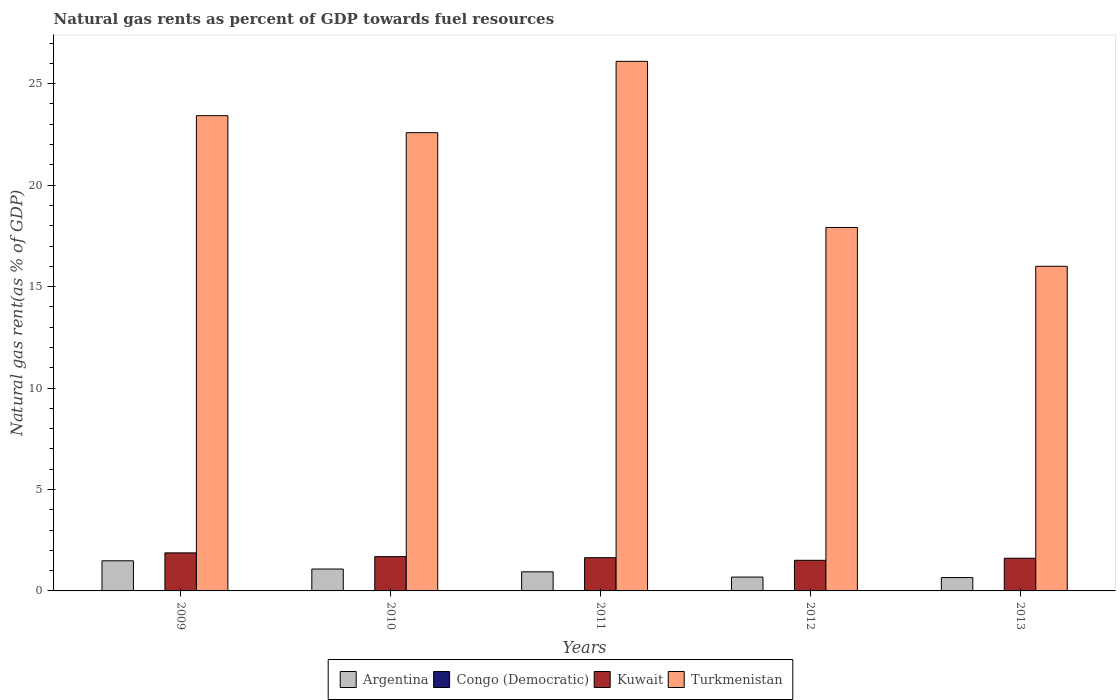How many bars are there on the 2nd tick from the left?
Your answer should be compact. 4. How many bars are there on the 1st tick from the right?
Your response must be concise. 4. What is the label of the 3rd group of bars from the left?
Make the answer very short. 2011. What is the natural gas rent in Turkmenistan in 2010?
Offer a very short reply. 22.59. Across all years, what is the maximum natural gas rent in Kuwait?
Your response must be concise. 1.88. Across all years, what is the minimum natural gas rent in Kuwait?
Your answer should be very brief. 1.51. What is the total natural gas rent in Congo (Democratic) in the graph?
Make the answer very short. 0.03. What is the difference between the natural gas rent in Argentina in 2009 and that in 2013?
Your answer should be very brief. 0.83. What is the difference between the natural gas rent in Congo (Democratic) in 2011 and the natural gas rent in Turkmenistan in 2010?
Your response must be concise. -22.58. What is the average natural gas rent in Argentina per year?
Ensure brevity in your answer.  0.97. In the year 2012, what is the difference between the natural gas rent in Congo (Democratic) and natural gas rent in Kuwait?
Give a very brief answer. -1.5. In how many years, is the natural gas rent in Turkmenistan greater than 21 %?
Your response must be concise. 3. What is the ratio of the natural gas rent in Kuwait in 2009 to that in 2010?
Provide a succinct answer. 1.11. Is the natural gas rent in Turkmenistan in 2009 less than that in 2011?
Make the answer very short. Yes. Is the difference between the natural gas rent in Congo (Democratic) in 2011 and 2012 greater than the difference between the natural gas rent in Kuwait in 2011 and 2012?
Offer a terse response. No. What is the difference between the highest and the second highest natural gas rent in Turkmenistan?
Make the answer very short. 2.68. What is the difference between the highest and the lowest natural gas rent in Kuwait?
Your answer should be very brief. 0.37. In how many years, is the natural gas rent in Congo (Democratic) greater than the average natural gas rent in Congo (Democratic) taken over all years?
Keep it short and to the point. 3. What does the 4th bar from the left in 2011 represents?
Offer a very short reply. Turkmenistan. What does the 1st bar from the right in 2013 represents?
Offer a terse response. Turkmenistan. How many bars are there?
Keep it short and to the point. 20. Are all the bars in the graph horizontal?
Make the answer very short. No. Are the values on the major ticks of Y-axis written in scientific E-notation?
Your response must be concise. No. Does the graph contain grids?
Give a very brief answer. No. Where does the legend appear in the graph?
Offer a terse response. Bottom center. How are the legend labels stacked?
Make the answer very short. Horizontal. What is the title of the graph?
Offer a terse response. Natural gas rents as percent of GDP towards fuel resources. What is the label or title of the Y-axis?
Offer a terse response. Natural gas rent(as % of GDP). What is the Natural gas rent(as % of GDP) in Argentina in 2009?
Provide a short and direct response. 1.48. What is the Natural gas rent(as % of GDP) of Congo (Democratic) in 2009?
Ensure brevity in your answer.  0.01. What is the Natural gas rent(as % of GDP) in Kuwait in 2009?
Provide a succinct answer. 1.88. What is the Natural gas rent(as % of GDP) in Turkmenistan in 2009?
Your answer should be very brief. 23.42. What is the Natural gas rent(as % of GDP) of Argentina in 2010?
Provide a succinct answer. 1.08. What is the Natural gas rent(as % of GDP) of Congo (Democratic) in 2010?
Give a very brief answer. 0.01. What is the Natural gas rent(as % of GDP) of Kuwait in 2010?
Make the answer very short. 1.69. What is the Natural gas rent(as % of GDP) in Turkmenistan in 2010?
Offer a very short reply. 22.59. What is the Natural gas rent(as % of GDP) of Argentina in 2011?
Ensure brevity in your answer.  0.94. What is the Natural gas rent(as % of GDP) of Congo (Democratic) in 2011?
Your response must be concise. 0.01. What is the Natural gas rent(as % of GDP) in Kuwait in 2011?
Ensure brevity in your answer.  1.64. What is the Natural gas rent(as % of GDP) in Turkmenistan in 2011?
Provide a short and direct response. 26.1. What is the Natural gas rent(as % of GDP) in Argentina in 2012?
Offer a terse response. 0.68. What is the Natural gas rent(as % of GDP) in Congo (Democratic) in 2012?
Your response must be concise. 0. What is the Natural gas rent(as % of GDP) in Kuwait in 2012?
Provide a short and direct response. 1.51. What is the Natural gas rent(as % of GDP) in Turkmenistan in 2012?
Provide a succinct answer. 17.91. What is the Natural gas rent(as % of GDP) of Argentina in 2013?
Give a very brief answer. 0.66. What is the Natural gas rent(as % of GDP) of Congo (Democratic) in 2013?
Keep it short and to the point. 0. What is the Natural gas rent(as % of GDP) in Kuwait in 2013?
Offer a very short reply. 1.61. What is the Natural gas rent(as % of GDP) of Turkmenistan in 2013?
Keep it short and to the point. 16. Across all years, what is the maximum Natural gas rent(as % of GDP) of Argentina?
Make the answer very short. 1.48. Across all years, what is the maximum Natural gas rent(as % of GDP) of Congo (Democratic)?
Your answer should be very brief. 0.01. Across all years, what is the maximum Natural gas rent(as % of GDP) of Kuwait?
Give a very brief answer. 1.88. Across all years, what is the maximum Natural gas rent(as % of GDP) of Turkmenistan?
Offer a terse response. 26.1. Across all years, what is the minimum Natural gas rent(as % of GDP) in Argentina?
Your answer should be compact. 0.66. Across all years, what is the minimum Natural gas rent(as % of GDP) of Congo (Democratic)?
Your answer should be compact. 0. Across all years, what is the minimum Natural gas rent(as % of GDP) in Kuwait?
Provide a succinct answer. 1.51. Across all years, what is the minimum Natural gas rent(as % of GDP) of Turkmenistan?
Ensure brevity in your answer.  16. What is the total Natural gas rent(as % of GDP) of Argentina in the graph?
Provide a succinct answer. 4.85. What is the total Natural gas rent(as % of GDP) in Congo (Democratic) in the graph?
Provide a short and direct response. 0.03. What is the total Natural gas rent(as % of GDP) in Kuwait in the graph?
Offer a very short reply. 8.32. What is the total Natural gas rent(as % of GDP) in Turkmenistan in the graph?
Your answer should be very brief. 106.03. What is the difference between the Natural gas rent(as % of GDP) in Argentina in 2009 and that in 2010?
Provide a succinct answer. 0.41. What is the difference between the Natural gas rent(as % of GDP) in Congo (Democratic) in 2009 and that in 2010?
Your answer should be very brief. 0. What is the difference between the Natural gas rent(as % of GDP) of Kuwait in 2009 and that in 2010?
Give a very brief answer. 0.19. What is the difference between the Natural gas rent(as % of GDP) of Turkmenistan in 2009 and that in 2010?
Offer a very short reply. 0.84. What is the difference between the Natural gas rent(as % of GDP) of Argentina in 2009 and that in 2011?
Provide a short and direct response. 0.54. What is the difference between the Natural gas rent(as % of GDP) of Congo (Democratic) in 2009 and that in 2011?
Make the answer very short. 0. What is the difference between the Natural gas rent(as % of GDP) in Kuwait in 2009 and that in 2011?
Give a very brief answer. 0.24. What is the difference between the Natural gas rent(as % of GDP) in Turkmenistan in 2009 and that in 2011?
Make the answer very short. -2.68. What is the difference between the Natural gas rent(as % of GDP) of Argentina in 2009 and that in 2012?
Keep it short and to the point. 0.8. What is the difference between the Natural gas rent(as % of GDP) in Congo (Democratic) in 2009 and that in 2012?
Provide a succinct answer. 0. What is the difference between the Natural gas rent(as % of GDP) of Kuwait in 2009 and that in 2012?
Keep it short and to the point. 0.37. What is the difference between the Natural gas rent(as % of GDP) in Turkmenistan in 2009 and that in 2012?
Offer a terse response. 5.51. What is the difference between the Natural gas rent(as % of GDP) in Argentina in 2009 and that in 2013?
Make the answer very short. 0.83. What is the difference between the Natural gas rent(as % of GDP) of Congo (Democratic) in 2009 and that in 2013?
Offer a terse response. 0. What is the difference between the Natural gas rent(as % of GDP) in Kuwait in 2009 and that in 2013?
Your response must be concise. 0.26. What is the difference between the Natural gas rent(as % of GDP) of Turkmenistan in 2009 and that in 2013?
Make the answer very short. 7.42. What is the difference between the Natural gas rent(as % of GDP) in Argentina in 2010 and that in 2011?
Ensure brevity in your answer.  0.14. What is the difference between the Natural gas rent(as % of GDP) in Kuwait in 2010 and that in 2011?
Your answer should be very brief. 0.05. What is the difference between the Natural gas rent(as % of GDP) in Turkmenistan in 2010 and that in 2011?
Keep it short and to the point. -3.52. What is the difference between the Natural gas rent(as % of GDP) of Argentina in 2010 and that in 2012?
Your answer should be compact. 0.4. What is the difference between the Natural gas rent(as % of GDP) of Congo (Democratic) in 2010 and that in 2012?
Make the answer very short. 0. What is the difference between the Natural gas rent(as % of GDP) of Kuwait in 2010 and that in 2012?
Provide a short and direct response. 0.18. What is the difference between the Natural gas rent(as % of GDP) in Turkmenistan in 2010 and that in 2012?
Offer a very short reply. 4.67. What is the difference between the Natural gas rent(as % of GDP) of Argentina in 2010 and that in 2013?
Your response must be concise. 0.42. What is the difference between the Natural gas rent(as % of GDP) in Congo (Democratic) in 2010 and that in 2013?
Keep it short and to the point. 0. What is the difference between the Natural gas rent(as % of GDP) in Kuwait in 2010 and that in 2013?
Your answer should be compact. 0.08. What is the difference between the Natural gas rent(as % of GDP) of Turkmenistan in 2010 and that in 2013?
Your answer should be very brief. 6.59. What is the difference between the Natural gas rent(as % of GDP) of Argentina in 2011 and that in 2012?
Offer a terse response. 0.26. What is the difference between the Natural gas rent(as % of GDP) of Congo (Democratic) in 2011 and that in 2012?
Ensure brevity in your answer.  0. What is the difference between the Natural gas rent(as % of GDP) in Kuwait in 2011 and that in 2012?
Provide a succinct answer. 0.13. What is the difference between the Natural gas rent(as % of GDP) in Turkmenistan in 2011 and that in 2012?
Your answer should be very brief. 8.19. What is the difference between the Natural gas rent(as % of GDP) in Argentina in 2011 and that in 2013?
Your answer should be very brief. 0.28. What is the difference between the Natural gas rent(as % of GDP) of Congo (Democratic) in 2011 and that in 2013?
Keep it short and to the point. 0. What is the difference between the Natural gas rent(as % of GDP) in Kuwait in 2011 and that in 2013?
Ensure brevity in your answer.  0.03. What is the difference between the Natural gas rent(as % of GDP) in Turkmenistan in 2011 and that in 2013?
Provide a short and direct response. 10.1. What is the difference between the Natural gas rent(as % of GDP) in Argentina in 2012 and that in 2013?
Your answer should be very brief. 0.02. What is the difference between the Natural gas rent(as % of GDP) of Kuwait in 2012 and that in 2013?
Provide a succinct answer. -0.1. What is the difference between the Natural gas rent(as % of GDP) in Turkmenistan in 2012 and that in 2013?
Offer a very short reply. 1.91. What is the difference between the Natural gas rent(as % of GDP) in Argentina in 2009 and the Natural gas rent(as % of GDP) in Congo (Democratic) in 2010?
Give a very brief answer. 1.48. What is the difference between the Natural gas rent(as % of GDP) of Argentina in 2009 and the Natural gas rent(as % of GDP) of Kuwait in 2010?
Offer a very short reply. -0.2. What is the difference between the Natural gas rent(as % of GDP) of Argentina in 2009 and the Natural gas rent(as % of GDP) of Turkmenistan in 2010?
Offer a terse response. -21.1. What is the difference between the Natural gas rent(as % of GDP) of Congo (Democratic) in 2009 and the Natural gas rent(as % of GDP) of Kuwait in 2010?
Offer a very short reply. -1.68. What is the difference between the Natural gas rent(as % of GDP) in Congo (Democratic) in 2009 and the Natural gas rent(as % of GDP) in Turkmenistan in 2010?
Keep it short and to the point. -22.58. What is the difference between the Natural gas rent(as % of GDP) in Kuwait in 2009 and the Natural gas rent(as % of GDP) in Turkmenistan in 2010?
Your response must be concise. -20.71. What is the difference between the Natural gas rent(as % of GDP) of Argentina in 2009 and the Natural gas rent(as % of GDP) of Congo (Democratic) in 2011?
Keep it short and to the point. 1.48. What is the difference between the Natural gas rent(as % of GDP) in Argentina in 2009 and the Natural gas rent(as % of GDP) in Kuwait in 2011?
Offer a terse response. -0.15. What is the difference between the Natural gas rent(as % of GDP) in Argentina in 2009 and the Natural gas rent(as % of GDP) in Turkmenistan in 2011?
Give a very brief answer. -24.62. What is the difference between the Natural gas rent(as % of GDP) in Congo (Democratic) in 2009 and the Natural gas rent(as % of GDP) in Kuwait in 2011?
Ensure brevity in your answer.  -1.63. What is the difference between the Natural gas rent(as % of GDP) in Congo (Democratic) in 2009 and the Natural gas rent(as % of GDP) in Turkmenistan in 2011?
Make the answer very short. -26.09. What is the difference between the Natural gas rent(as % of GDP) in Kuwait in 2009 and the Natural gas rent(as % of GDP) in Turkmenistan in 2011?
Offer a very short reply. -24.23. What is the difference between the Natural gas rent(as % of GDP) of Argentina in 2009 and the Natural gas rent(as % of GDP) of Congo (Democratic) in 2012?
Make the answer very short. 1.48. What is the difference between the Natural gas rent(as % of GDP) of Argentina in 2009 and the Natural gas rent(as % of GDP) of Kuwait in 2012?
Provide a succinct answer. -0.02. What is the difference between the Natural gas rent(as % of GDP) of Argentina in 2009 and the Natural gas rent(as % of GDP) of Turkmenistan in 2012?
Your response must be concise. -16.43. What is the difference between the Natural gas rent(as % of GDP) in Congo (Democratic) in 2009 and the Natural gas rent(as % of GDP) in Kuwait in 2012?
Your response must be concise. -1.5. What is the difference between the Natural gas rent(as % of GDP) in Congo (Democratic) in 2009 and the Natural gas rent(as % of GDP) in Turkmenistan in 2012?
Provide a short and direct response. -17.91. What is the difference between the Natural gas rent(as % of GDP) of Kuwait in 2009 and the Natural gas rent(as % of GDP) of Turkmenistan in 2012?
Your response must be concise. -16.04. What is the difference between the Natural gas rent(as % of GDP) in Argentina in 2009 and the Natural gas rent(as % of GDP) in Congo (Democratic) in 2013?
Offer a very short reply. 1.48. What is the difference between the Natural gas rent(as % of GDP) of Argentina in 2009 and the Natural gas rent(as % of GDP) of Kuwait in 2013?
Keep it short and to the point. -0.13. What is the difference between the Natural gas rent(as % of GDP) of Argentina in 2009 and the Natural gas rent(as % of GDP) of Turkmenistan in 2013?
Your answer should be compact. -14.52. What is the difference between the Natural gas rent(as % of GDP) of Congo (Democratic) in 2009 and the Natural gas rent(as % of GDP) of Kuwait in 2013?
Keep it short and to the point. -1.6. What is the difference between the Natural gas rent(as % of GDP) in Congo (Democratic) in 2009 and the Natural gas rent(as % of GDP) in Turkmenistan in 2013?
Your answer should be compact. -15.99. What is the difference between the Natural gas rent(as % of GDP) of Kuwait in 2009 and the Natural gas rent(as % of GDP) of Turkmenistan in 2013?
Provide a short and direct response. -14.12. What is the difference between the Natural gas rent(as % of GDP) in Argentina in 2010 and the Natural gas rent(as % of GDP) in Congo (Democratic) in 2011?
Provide a succinct answer. 1.07. What is the difference between the Natural gas rent(as % of GDP) in Argentina in 2010 and the Natural gas rent(as % of GDP) in Kuwait in 2011?
Offer a terse response. -0.56. What is the difference between the Natural gas rent(as % of GDP) of Argentina in 2010 and the Natural gas rent(as % of GDP) of Turkmenistan in 2011?
Give a very brief answer. -25.02. What is the difference between the Natural gas rent(as % of GDP) in Congo (Democratic) in 2010 and the Natural gas rent(as % of GDP) in Kuwait in 2011?
Provide a succinct answer. -1.63. What is the difference between the Natural gas rent(as % of GDP) of Congo (Democratic) in 2010 and the Natural gas rent(as % of GDP) of Turkmenistan in 2011?
Keep it short and to the point. -26.1. What is the difference between the Natural gas rent(as % of GDP) of Kuwait in 2010 and the Natural gas rent(as % of GDP) of Turkmenistan in 2011?
Your answer should be compact. -24.41. What is the difference between the Natural gas rent(as % of GDP) of Argentina in 2010 and the Natural gas rent(as % of GDP) of Congo (Democratic) in 2012?
Provide a short and direct response. 1.07. What is the difference between the Natural gas rent(as % of GDP) in Argentina in 2010 and the Natural gas rent(as % of GDP) in Kuwait in 2012?
Offer a very short reply. -0.43. What is the difference between the Natural gas rent(as % of GDP) in Argentina in 2010 and the Natural gas rent(as % of GDP) in Turkmenistan in 2012?
Make the answer very short. -16.83. What is the difference between the Natural gas rent(as % of GDP) in Congo (Democratic) in 2010 and the Natural gas rent(as % of GDP) in Kuwait in 2012?
Make the answer very short. -1.5. What is the difference between the Natural gas rent(as % of GDP) of Congo (Democratic) in 2010 and the Natural gas rent(as % of GDP) of Turkmenistan in 2012?
Your answer should be compact. -17.91. What is the difference between the Natural gas rent(as % of GDP) in Kuwait in 2010 and the Natural gas rent(as % of GDP) in Turkmenistan in 2012?
Provide a succinct answer. -16.22. What is the difference between the Natural gas rent(as % of GDP) in Argentina in 2010 and the Natural gas rent(as % of GDP) in Congo (Democratic) in 2013?
Offer a very short reply. 1.07. What is the difference between the Natural gas rent(as % of GDP) in Argentina in 2010 and the Natural gas rent(as % of GDP) in Kuwait in 2013?
Your answer should be compact. -0.53. What is the difference between the Natural gas rent(as % of GDP) in Argentina in 2010 and the Natural gas rent(as % of GDP) in Turkmenistan in 2013?
Provide a succinct answer. -14.92. What is the difference between the Natural gas rent(as % of GDP) in Congo (Democratic) in 2010 and the Natural gas rent(as % of GDP) in Kuwait in 2013?
Make the answer very short. -1.61. What is the difference between the Natural gas rent(as % of GDP) of Congo (Democratic) in 2010 and the Natural gas rent(as % of GDP) of Turkmenistan in 2013?
Give a very brief answer. -15.99. What is the difference between the Natural gas rent(as % of GDP) in Kuwait in 2010 and the Natural gas rent(as % of GDP) in Turkmenistan in 2013?
Your response must be concise. -14.31. What is the difference between the Natural gas rent(as % of GDP) of Argentina in 2011 and the Natural gas rent(as % of GDP) of Congo (Democratic) in 2012?
Provide a succinct answer. 0.94. What is the difference between the Natural gas rent(as % of GDP) of Argentina in 2011 and the Natural gas rent(as % of GDP) of Kuwait in 2012?
Give a very brief answer. -0.57. What is the difference between the Natural gas rent(as % of GDP) in Argentina in 2011 and the Natural gas rent(as % of GDP) in Turkmenistan in 2012?
Offer a terse response. -16.97. What is the difference between the Natural gas rent(as % of GDP) of Congo (Democratic) in 2011 and the Natural gas rent(as % of GDP) of Kuwait in 2012?
Your answer should be compact. -1.5. What is the difference between the Natural gas rent(as % of GDP) of Congo (Democratic) in 2011 and the Natural gas rent(as % of GDP) of Turkmenistan in 2012?
Keep it short and to the point. -17.91. What is the difference between the Natural gas rent(as % of GDP) of Kuwait in 2011 and the Natural gas rent(as % of GDP) of Turkmenistan in 2012?
Keep it short and to the point. -16.28. What is the difference between the Natural gas rent(as % of GDP) in Argentina in 2011 and the Natural gas rent(as % of GDP) in Congo (Democratic) in 2013?
Your answer should be very brief. 0.94. What is the difference between the Natural gas rent(as % of GDP) in Argentina in 2011 and the Natural gas rent(as % of GDP) in Kuwait in 2013?
Keep it short and to the point. -0.67. What is the difference between the Natural gas rent(as % of GDP) in Argentina in 2011 and the Natural gas rent(as % of GDP) in Turkmenistan in 2013?
Keep it short and to the point. -15.06. What is the difference between the Natural gas rent(as % of GDP) of Congo (Democratic) in 2011 and the Natural gas rent(as % of GDP) of Kuwait in 2013?
Give a very brief answer. -1.61. What is the difference between the Natural gas rent(as % of GDP) of Congo (Democratic) in 2011 and the Natural gas rent(as % of GDP) of Turkmenistan in 2013?
Make the answer very short. -15.99. What is the difference between the Natural gas rent(as % of GDP) in Kuwait in 2011 and the Natural gas rent(as % of GDP) in Turkmenistan in 2013?
Give a very brief answer. -14.36. What is the difference between the Natural gas rent(as % of GDP) of Argentina in 2012 and the Natural gas rent(as % of GDP) of Congo (Democratic) in 2013?
Offer a terse response. 0.68. What is the difference between the Natural gas rent(as % of GDP) of Argentina in 2012 and the Natural gas rent(as % of GDP) of Kuwait in 2013?
Ensure brevity in your answer.  -0.93. What is the difference between the Natural gas rent(as % of GDP) in Argentina in 2012 and the Natural gas rent(as % of GDP) in Turkmenistan in 2013?
Your answer should be compact. -15.32. What is the difference between the Natural gas rent(as % of GDP) of Congo (Democratic) in 2012 and the Natural gas rent(as % of GDP) of Kuwait in 2013?
Make the answer very short. -1.61. What is the difference between the Natural gas rent(as % of GDP) of Congo (Democratic) in 2012 and the Natural gas rent(as % of GDP) of Turkmenistan in 2013?
Provide a short and direct response. -16. What is the difference between the Natural gas rent(as % of GDP) of Kuwait in 2012 and the Natural gas rent(as % of GDP) of Turkmenistan in 2013?
Your answer should be compact. -14.49. What is the average Natural gas rent(as % of GDP) in Argentina per year?
Your answer should be compact. 0.97. What is the average Natural gas rent(as % of GDP) of Congo (Democratic) per year?
Provide a short and direct response. 0.01. What is the average Natural gas rent(as % of GDP) in Kuwait per year?
Give a very brief answer. 1.66. What is the average Natural gas rent(as % of GDP) in Turkmenistan per year?
Offer a terse response. 21.21. In the year 2009, what is the difference between the Natural gas rent(as % of GDP) of Argentina and Natural gas rent(as % of GDP) of Congo (Democratic)?
Give a very brief answer. 1.48. In the year 2009, what is the difference between the Natural gas rent(as % of GDP) of Argentina and Natural gas rent(as % of GDP) of Kuwait?
Give a very brief answer. -0.39. In the year 2009, what is the difference between the Natural gas rent(as % of GDP) of Argentina and Natural gas rent(as % of GDP) of Turkmenistan?
Your answer should be compact. -21.94. In the year 2009, what is the difference between the Natural gas rent(as % of GDP) of Congo (Democratic) and Natural gas rent(as % of GDP) of Kuwait?
Ensure brevity in your answer.  -1.87. In the year 2009, what is the difference between the Natural gas rent(as % of GDP) in Congo (Democratic) and Natural gas rent(as % of GDP) in Turkmenistan?
Give a very brief answer. -23.42. In the year 2009, what is the difference between the Natural gas rent(as % of GDP) of Kuwait and Natural gas rent(as % of GDP) of Turkmenistan?
Provide a succinct answer. -21.55. In the year 2010, what is the difference between the Natural gas rent(as % of GDP) of Argentina and Natural gas rent(as % of GDP) of Congo (Democratic)?
Your answer should be compact. 1.07. In the year 2010, what is the difference between the Natural gas rent(as % of GDP) of Argentina and Natural gas rent(as % of GDP) of Kuwait?
Keep it short and to the point. -0.61. In the year 2010, what is the difference between the Natural gas rent(as % of GDP) of Argentina and Natural gas rent(as % of GDP) of Turkmenistan?
Your answer should be compact. -21.51. In the year 2010, what is the difference between the Natural gas rent(as % of GDP) in Congo (Democratic) and Natural gas rent(as % of GDP) in Kuwait?
Make the answer very short. -1.68. In the year 2010, what is the difference between the Natural gas rent(as % of GDP) in Congo (Democratic) and Natural gas rent(as % of GDP) in Turkmenistan?
Make the answer very short. -22.58. In the year 2010, what is the difference between the Natural gas rent(as % of GDP) of Kuwait and Natural gas rent(as % of GDP) of Turkmenistan?
Offer a terse response. -20.9. In the year 2011, what is the difference between the Natural gas rent(as % of GDP) of Argentina and Natural gas rent(as % of GDP) of Congo (Democratic)?
Provide a succinct answer. 0.94. In the year 2011, what is the difference between the Natural gas rent(as % of GDP) of Argentina and Natural gas rent(as % of GDP) of Kuwait?
Give a very brief answer. -0.7. In the year 2011, what is the difference between the Natural gas rent(as % of GDP) of Argentina and Natural gas rent(as % of GDP) of Turkmenistan?
Offer a very short reply. -25.16. In the year 2011, what is the difference between the Natural gas rent(as % of GDP) of Congo (Democratic) and Natural gas rent(as % of GDP) of Kuwait?
Provide a short and direct response. -1.63. In the year 2011, what is the difference between the Natural gas rent(as % of GDP) in Congo (Democratic) and Natural gas rent(as % of GDP) in Turkmenistan?
Give a very brief answer. -26.1. In the year 2011, what is the difference between the Natural gas rent(as % of GDP) of Kuwait and Natural gas rent(as % of GDP) of Turkmenistan?
Offer a very short reply. -24.46. In the year 2012, what is the difference between the Natural gas rent(as % of GDP) in Argentina and Natural gas rent(as % of GDP) in Congo (Democratic)?
Offer a very short reply. 0.68. In the year 2012, what is the difference between the Natural gas rent(as % of GDP) of Argentina and Natural gas rent(as % of GDP) of Kuwait?
Provide a short and direct response. -0.83. In the year 2012, what is the difference between the Natural gas rent(as % of GDP) in Argentina and Natural gas rent(as % of GDP) in Turkmenistan?
Make the answer very short. -17.23. In the year 2012, what is the difference between the Natural gas rent(as % of GDP) in Congo (Democratic) and Natural gas rent(as % of GDP) in Kuwait?
Keep it short and to the point. -1.5. In the year 2012, what is the difference between the Natural gas rent(as % of GDP) of Congo (Democratic) and Natural gas rent(as % of GDP) of Turkmenistan?
Offer a very short reply. -17.91. In the year 2012, what is the difference between the Natural gas rent(as % of GDP) in Kuwait and Natural gas rent(as % of GDP) in Turkmenistan?
Offer a very short reply. -16.4. In the year 2013, what is the difference between the Natural gas rent(as % of GDP) in Argentina and Natural gas rent(as % of GDP) in Congo (Democratic)?
Provide a succinct answer. 0.65. In the year 2013, what is the difference between the Natural gas rent(as % of GDP) of Argentina and Natural gas rent(as % of GDP) of Kuwait?
Make the answer very short. -0.95. In the year 2013, what is the difference between the Natural gas rent(as % of GDP) of Argentina and Natural gas rent(as % of GDP) of Turkmenistan?
Provide a short and direct response. -15.34. In the year 2013, what is the difference between the Natural gas rent(as % of GDP) of Congo (Democratic) and Natural gas rent(as % of GDP) of Kuwait?
Give a very brief answer. -1.61. In the year 2013, what is the difference between the Natural gas rent(as % of GDP) in Congo (Democratic) and Natural gas rent(as % of GDP) in Turkmenistan?
Keep it short and to the point. -16. In the year 2013, what is the difference between the Natural gas rent(as % of GDP) in Kuwait and Natural gas rent(as % of GDP) in Turkmenistan?
Offer a terse response. -14.39. What is the ratio of the Natural gas rent(as % of GDP) of Argentina in 2009 to that in 2010?
Your answer should be very brief. 1.38. What is the ratio of the Natural gas rent(as % of GDP) in Congo (Democratic) in 2009 to that in 2010?
Your answer should be compact. 1.2. What is the ratio of the Natural gas rent(as % of GDP) in Kuwait in 2009 to that in 2010?
Provide a succinct answer. 1.11. What is the ratio of the Natural gas rent(as % of GDP) in Turkmenistan in 2009 to that in 2010?
Make the answer very short. 1.04. What is the ratio of the Natural gas rent(as % of GDP) in Argentina in 2009 to that in 2011?
Keep it short and to the point. 1.58. What is the ratio of the Natural gas rent(as % of GDP) of Congo (Democratic) in 2009 to that in 2011?
Offer a very short reply. 1.25. What is the ratio of the Natural gas rent(as % of GDP) in Kuwait in 2009 to that in 2011?
Your response must be concise. 1.14. What is the ratio of the Natural gas rent(as % of GDP) of Turkmenistan in 2009 to that in 2011?
Keep it short and to the point. 0.9. What is the ratio of the Natural gas rent(as % of GDP) in Argentina in 2009 to that in 2012?
Your response must be concise. 2.17. What is the ratio of the Natural gas rent(as % of GDP) of Congo (Democratic) in 2009 to that in 2012?
Give a very brief answer. 1.67. What is the ratio of the Natural gas rent(as % of GDP) of Kuwait in 2009 to that in 2012?
Your answer should be compact. 1.24. What is the ratio of the Natural gas rent(as % of GDP) in Turkmenistan in 2009 to that in 2012?
Offer a terse response. 1.31. What is the ratio of the Natural gas rent(as % of GDP) in Argentina in 2009 to that in 2013?
Provide a short and direct response. 2.25. What is the ratio of the Natural gas rent(as % of GDP) of Congo (Democratic) in 2009 to that in 2013?
Your answer should be very brief. 1.66. What is the ratio of the Natural gas rent(as % of GDP) in Kuwait in 2009 to that in 2013?
Provide a short and direct response. 1.16. What is the ratio of the Natural gas rent(as % of GDP) in Turkmenistan in 2009 to that in 2013?
Give a very brief answer. 1.46. What is the ratio of the Natural gas rent(as % of GDP) in Argentina in 2010 to that in 2011?
Your response must be concise. 1.15. What is the ratio of the Natural gas rent(as % of GDP) in Congo (Democratic) in 2010 to that in 2011?
Provide a succinct answer. 1.05. What is the ratio of the Natural gas rent(as % of GDP) of Kuwait in 2010 to that in 2011?
Offer a very short reply. 1.03. What is the ratio of the Natural gas rent(as % of GDP) of Turkmenistan in 2010 to that in 2011?
Your response must be concise. 0.87. What is the ratio of the Natural gas rent(as % of GDP) in Argentina in 2010 to that in 2012?
Your response must be concise. 1.58. What is the ratio of the Natural gas rent(as % of GDP) in Congo (Democratic) in 2010 to that in 2012?
Make the answer very short. 1.4. What is the ratio of the Natural gas rent(as % of GDP) of Kuwait in 2010 to that in 2012?
Ensure brevity in your answer.  1.12. What is the ratio of the Natural gas rent(as % of GDP) in Turkmenistan in 2010 to that in 2012?
Your answer should be very brief. 1.26. What is the ratio of the Natural gas rent(as % of GDP) of Argentina in 2010 to that in 2013?
Provide a succinct answer. 1.64. What is the ratio of the Natural gas rent(as % of GDP) in Congo (Democratic) in 2010 to that in 2013?
Your answer should be very brief. 1.39. What is the ratio of the Natural gas rent(as % of GDP) of Kuwait in 2010 to that in 2013?
Provide a short and direct response. 1.05. What is the ratio of the Natural gas rent(as % of GDP) of Turkmenistan in 2010 to that in 2013?
Your answer should be very brief. 1.41. What is the ratio of the Natural gas rent(as % of GDP) of Argentina in 2011 to that in 2012?
Your response must be concise. 1.38. What is the ratio of the Natural gas rent(as % of GDP) in Congo (Democratic) in 2011 to that in 2012?
Offer a very short reply. 1.33. What is the ratio of the Natural gas rent(as % of GDP) of Kuwait in 2011 to that in 2012?
Your answer should be compact. 1.09. What is the ratio of the Natural gas rent(as % of GDP) of Turkmenistan in 2011 to that in 2012?
Provide a short and direct response. 1.46. What is the ratio of the Natural gas rent(as % of GDP) of Argentina in 2011 to that in 2013?
Your response must be concise. 1.43. What is the ratio of the Natural gas rent(as % of GDP) of Congo (Democratic) in 2011 to that in 2013?
Offer a very short reply. 1.33. What is the ratio of the Natural gas rent(as % of GDP) of Kuwait in 2011 to that in 2013?
Your response must be concise. 1.02. What is the ratio of the Natural gas rent(as % of GDP) in Turkmenistan in 2011 to that in 2013?
Give a very brief answer. 1.63. What is the ratio of the Natural gas rent(as % of GDP) of Argentina in 2012 to that in 2013?
Provide a short and direct response. 1.04. What is the ratio of the Natural gas rent(as % of GDP) of Congo (Democratic) in 2012 to that in 2013?
Offer a terse response. 1. What is the ratio of the Natural gas rent(as % of GDP) in Kuwait in 2012 to that in 2013?
Provide a succinct answer. 0.94. What is the ratio of the Natural gas rent(as % of GDP) of Turkmenistan in 2012 to that in 2013?
Your answer should be very brief. 1.12. What is the difference between the highest and the second highest Natural gas rent(as % of GDP) in Argentina?
Offer a very short reply. 0.41. What is the difference between the highest and the second highest Natural gas rent(as % of GDP) of Congo (Democratic)?
Offer a terse response. 0. What is the difference between the highest and the second highest Natural gas rent(as % of GDP) in Kuwait?
Give a very brief answer. 0.19. What is the difference between the highest and the second highest Natural gas rent(as % of GDP) of Turkmenistan?
Give a very brief answer. 2.68. What is the difference between the highest and the lowest Natural gas rent(as % of GDP) in Argentina?
Offer a terse response. 0.83. What is the difference between the highest and the lowest Natural gas rent(as % of GDP) of Congo (Democratic)?
Give a very brief answer. 0. What is the difference between the highest and the lowest Natural gas rent(as % of GDP) of Kuwait?
Your answer should be very brief. 0.37. What is the difference between the highest and the lowest Natural gas rent(as % of GDP) in Turkmenistan?
Provide a short and direct response. 10.1. 